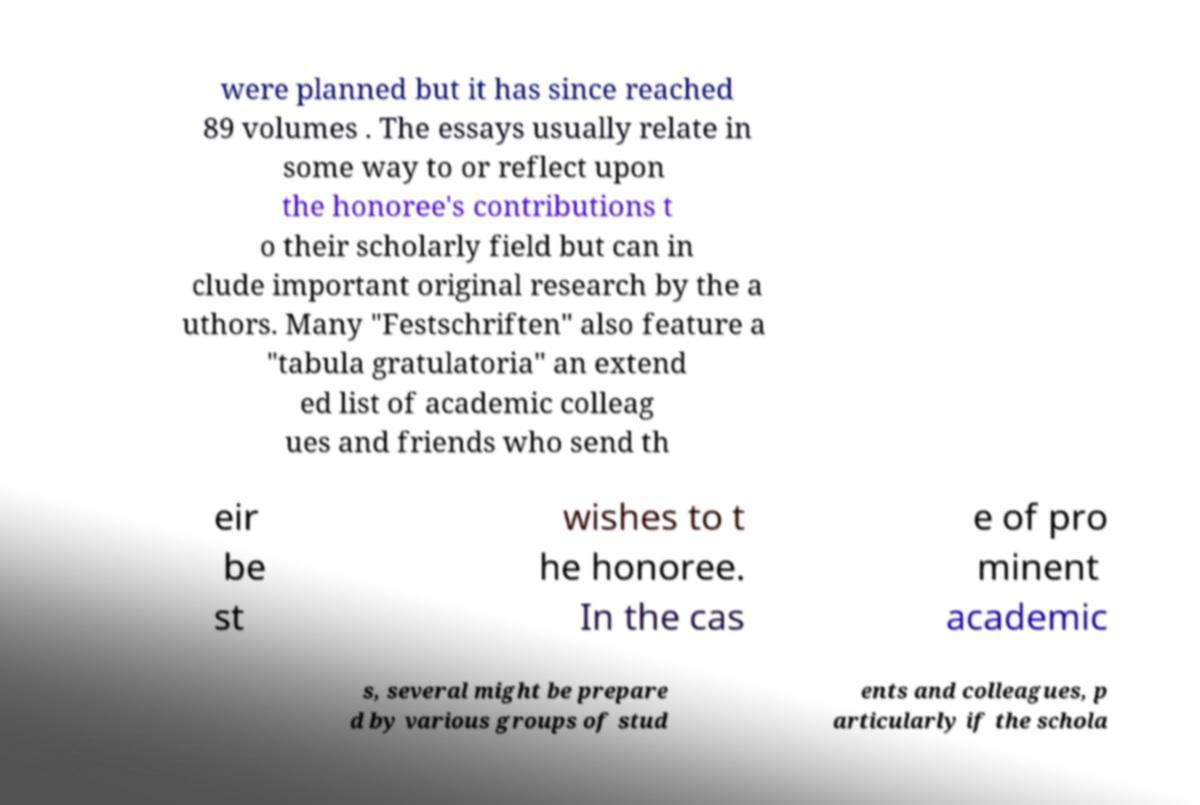Please identify and transcribe the text found in this image. were planned but it has since reached 89 volumes . The essays usually relate in some way to or reflect upon the honoree's contributions t o their scholarly field but can in clude important original research by the a uthors. Many "Festschriften" also feature a "tabula gratulatoria" an extend ed list of academic colleag ues and friends who send th eir be st wishes to t he honoree. In the cas e of pro minent academic s, several might be prepare d by various groups of stud ents and colleagues, p articularly if the schola 